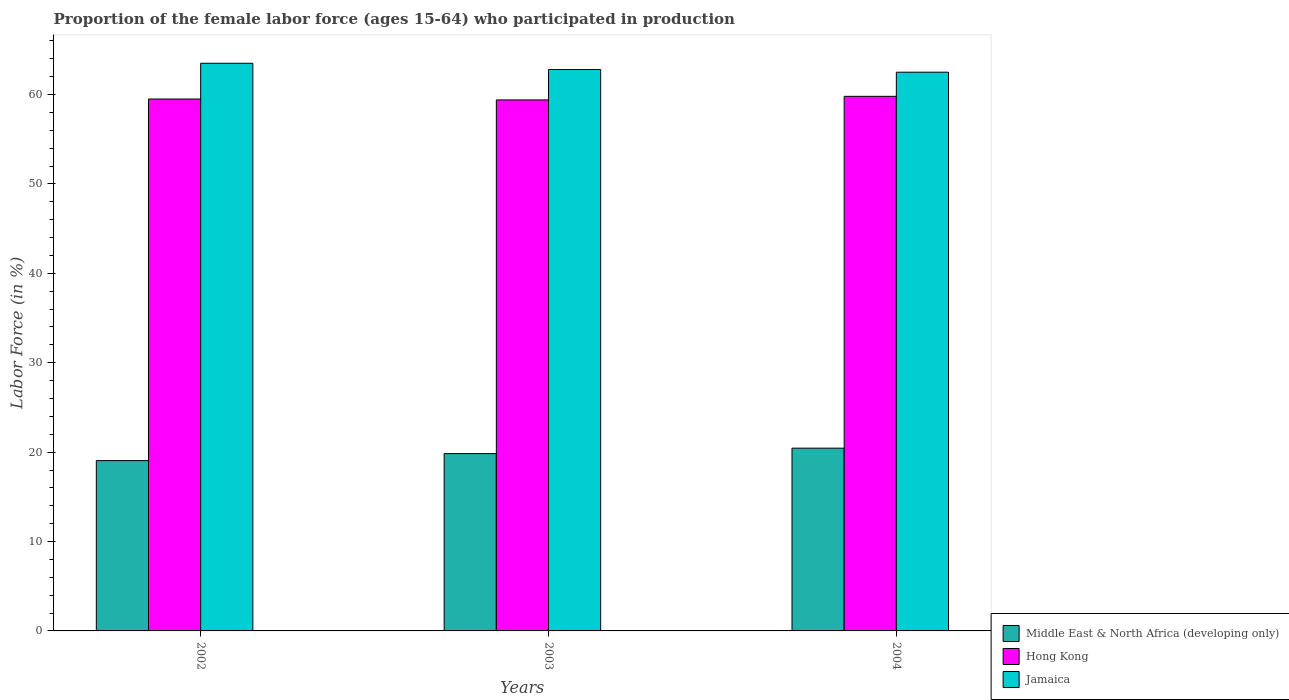How many different coloured bars are there?
Provide a short and direct response. 3. How many groups of bars are there?
Keep it short and to the point. 3. Are the number of bars per tick equal to the number of legend labels?
Keep it short and to the point. Yes. Are the number of bars on each tick of the X-axis equal?
Make the answer very short. Yes. How many bars are there on the 3rd tick from the right?
Your answer should be very brief. 3. What is the label of the 2nd group of bars from the left?
Offer a very short reply. 2003. In how many cases, is the number of bars for a given year not equal to the number of legend labels?
Provide a succinct answer. 0. What is the proportion of the female labor force who participated in production in Middle East & North Africa (developing only) in 2004?
Your response must be concise. 20.44. Across all years, what is the maximum proportion of the female labor force who participated in production in Hong Kong?
Your response must be concise. 59.8. Across all years, what is the minimum proportion of the female labor force who participated in production in Hong Kong?
Give a very brief answer. 59.4. In which year was the proportion of the female labor force who participated in production in Jamaica maximum?
Ensure brevity in your answer.  2002. In which year was the proportion of the female labor force who participated in production in Middle East & North Africa (developing only) minimum?
Your answer should be compact. 2002. What is the total proportion of the female labor force who participated in production in Middle East & North Africa (developing only) in the graph?
Give a very brief answer. 59.33. What is the difference between the proportion of the female labor force who participated in production in Middle East & North Africa (developing only) in 2002 and that in 2003?
Give a very brief answer. -0.78. What is the difference between the proportion of the female labor force who participated in production in Hong Kong in 2003 and the proportion of the female labor force who participated in production in Middle East & North Africa (developing only) in 2004?
Offer a very short reply. 38.96. What is the average proportion of the female labor force who participated in production in Jamaica per year?
Offer a very short reply. 62.93. In the year 2004, what is the difference between the proportion of the female labor force who participated in production in Jamaica and proportion of the female labor force who participated in production in Hong Kong?
Your answer should be very brief. 2.7. What is the ratio of the proportion of the female labor force who participated in production in Jamaica in 2002 to that in 2003?
Your answer should be compact. 1.01. Is the proportion of the female labor force who participated in production in Middle East & North Africa (developing only) in 2002 less than that in 2004?
Make the answer very short. Yes. Is the difference between the proportion of the female labor force who participated in production in Jamaica in 2002 and 2003 greater than the difference between the proportion of the female labor force who participated in production in Hong Kong in 2002 and 2003?
Keep it short and to the point. Yes. What is the difference between the highest and the second highest proportion of the female labor force who participated in production in Middle East & North Africa (developing only)?
Your response must be concise. 0.61. What is the difference between the highest and the lowest proportion of the female labor force who participated in production in Middle East & North Africa (developing only)?
Your response must be concise. 1.39. What does the 3rd bar from the left in 2003 represents?
Provide a succinct answer. Jamaica. What does the 1st bar from the right in 2003 represents?
Make the answer very short. Jamaica. How many bars are there?
Give a very brief answer. 9. Are all the bars in the graph horizontal?
Give a very brief answer. No. How many years are there in the graph?
Provide a short and direct response. 3. What is the difference between two consecutive major ticks on the Y-axis?
Your answer should be compact. 10. Are the values on the major ticks of Y-axis written in scientific E-notation?
Your answer should be very brief. No. How many legend labels are there?
Offer a very short reply. 3. What is the title of the graph?
Your response must be concise. Proportion of the female labor force (ages 15-64) who participated in production. What is the Labor Force (in %) of Middle East & North Africa (developing only) in 2002?
Your answer should be very brief. 19.05. What is the Labor Force (in %) of Hong Kong in 2002?
Your answer should be very brief. 59.5. What is the Labor Force (in %) in Jamaica in 2002?
Keep it short and to the point. 63.5. What is the Labor Force (in %) of Middle East & North Africa (developing only) in 2003?
Offer a very short reply. 19.84. What is the Labor Force (in %) in Hong Kong in 2003?
Give a very brief answer. 59.4. What is the Labor Force (in %) in Jamaica in 2003?
Provide a short and direct response. 62.8. What is the Labor Force (in %) of Middle East & North Africa (developing only) in 2004?
Your response must be concise. 20.44. What is the Labor Force (in %) of Hong Kong in 2004?
Provide a short and direct response. 59.8. What is the Labor Force (in %) in Jamaica in 2004?
Make the answer very short. 62.5. Across all years, what is the maximum Labor Force (in %) in Middle East & North Africa (developing only)?
Provide a succinct answer. 20.44. Across all years, what is the maximum Labor Force (in %) in Hong Kong?
Provide a short and direct response. 59.8. Across all years, what is the maximum Labor Force (in %) of Jamaica?
Offer a very short reply. 63.5. Across all years, what is the minimum Labor Force (in %) of Middle East & North Africa (developing only)?
Provide a succinct answer. 19.05. Across all years, what is the minimum Labor Force (in %) of Hong Kong?
Provide a succinct answer. 59.4. Across all years, what is the minimum Labor Force (in %) in Jamaica?
Keep it short and to the point. 62.5. What is the total Labor Force (in %) in Middle East & North Africa (developing only) in the graph?
Ensure brevity in your answer.  59.33. What is the total Labor Force (in %) in Hong Kong in the graph?
Your response must be concise. 178.7. What is the total Labor Force (in %) of Jamaica in the graph?
Offer a very short reply. 188.8. What is the difference between the Labor Force (in %) of Middle East & North Africa (developing only) in 2002 and that in 2003?
Your response must be concise. -0.78. What is the difference between the Labor Force (in %) of Middle East & North Africa (developing only) in 2002 and that in 2004?
Provide a succinct answer. -1.39. What is the difference between the Labor Force (in %) in Jamaica in 2002 and that in 2004?
Offer a very short reply. 1. What is the difference between the Labor Force (in %) of Middle East & North Africa (developing only) in 2003 and that in 2004?
Your response must be concise. -0.61. What is the difference between the Labor Force (in %) of Hong Kong in 2003 and that in 2004?
Give a very brief answer. -0.4. What is the difference between the Labor Force (in %) in Middle East & North Africa (developing only) in 2002 and the Labor Force (in %) in Hong Kong in 2003?
Provide a succinct answer. -40.35. What is the difference between the Labor Force (in %) of Middle East & North Africa (developing only) in 2002 and the Labor Force (in %) of Jamaica in 2003?
Your response must be concise. -43.75. What is the difference between the Labor Force (in %) of Middle East & North Africa (developing only) in 2002 and the Labor Force (in %) of Hong Kong in 2004?
Offer a terse response. -40.75. What is the difference between the Labor Force (in %) of Middle East & North Africa (developing only) in 2002 and the Labor Force (in %) of Jamaica in 2004?
Your answer should be very brief. -43.45. What is the difference between the Labor Force (in %) in Hong Kong in 2002 and the Labor Force (in %) in Jamaica in 2004?
Offer a terse response. -3. What is the difference between the Labor Force (in %) in Middle East & North Africa (developing only) in 2003 and the Labor Force (in %) in Hong Kong in 2004?
Give a very brief answer. -39.96. What is the difference between the Labor Force (in %) of Middle East & North Africa (developing only) in 2003 and the Labor Force (in %) of Jamaica in 2004?
Provide a short and direct response. -42.66. What is the average Labor Force (in %) in Middle East & North Africa (developing only) per year?
Your response must be concise. 19.78. What is the average Labor Force (in %) in Hong Kong per year?
Ensure brevity in your answer.  59.57. What is the average Labor Force (in %) of Jamaica per year?
Make the answer very short. 62.93. In the year 2002, what is the difference between the Labor Force (in %) in Middle East & North Africa (developing only) and Labor Force (in %) in Hong Kong?
Your answer should be compact. -40.45. In the year 2002, what is the difference between the Labor Force (in %) of Middle East & North Africa (developing only) and Labor Force (in %) of Jamaica?
Make the answer very short. -44.45. In the year 2002, what is the difference between the Labor Force (in %) of Hong Kong and Labor Force (in %) of Jamaica?
Give a very brief answer. -4. In the year 2003, what is the difference between the Labor Force (in %) of Middle East & North Africa (developing only) and Labor Force (in %) of Hong Kong?
Offer a terse response. -39.56. In the year 2003, what is the difference between the Labor Force (in %) of Middle East & North Africa (developing only) and Labor Force (in %) of Jamaica?
Keep it short and to the point. -42.96. In the year 2004, what is the difference between the Labor Force (in %) in Middle East & North Africa (developing only) and Labor Force (in %) in Hong Kong?
Provide a short and direct response. -39.36. In the year 2004, what is the difference between the Labor Force (in %) in Middle East & North Africa (developing only) and Labor Force (in %) in Jamaica?
Make the answer very short. -42.06. What is the ratio of the Labor Force (in %) in Middle East & North Africa (developing only) in 2002 to that in 2003?
Provide a succinct answer. 0.96. What is the ratio of the Labor Force (in %) in Jamaica in 2002 to that in 2003?
Offer a terse response. 1.01. What is the ratio of the Labor Force (in %) of Middle East & North Africa (developing only) in 2002 to that in 2004?
Provide a succinct answer. 0.93. What is the ratio of the Labor Force (in %) of Hong Kong in 2002 to that in 2004?
Make the answer very short. 0.99. What is the ratio of the Labor Force (in %) in Middle East & North Africa (developing only) in 2003 to that in 2004?
Your answer should be very brief. 0.97. What is the difference between the highest and the second highest Labor Force (in %) of Middle East & North Africa (developing only)?
Give a very brief answer. 0.61. What is the difference between the highest and the second highest Labor Force (in %) in Hong Kong?
Give a very brief answer. 0.3. What is the difference between the highest and the second highest Labor Force (in %) of Jamaica?
Keep it short and to the point. 0.7. What is the difference between the highest and the lowest Labor Force (in %) of Middle East & North Africa (developing only)?
Provide a succinct answer. 1.39. 